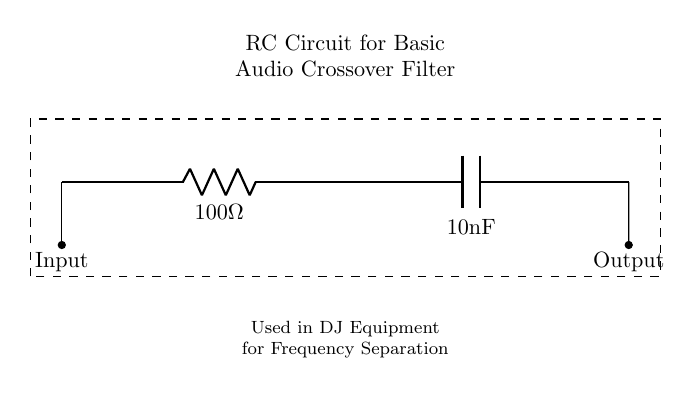What is the resistance value in this circuit? The resistance value is given directly in the circuit diagram next to the resistor symbol. It is labeled as 100 Ohms.
Answer: 100 Ohm What is the capacitance value in the circuit? The capacitance value is explicitly stated next to the capacitor symbol in the circuit diagram. It is labeled as 10 nanofarads.
Answer: 10 nanofarads What type of filter is this circuit designed to create? The RC circuit functions as a basic audio crossover filter, which is indicated in the title within the dashed rectangle of the circuit diagram.
Answer: Audio crossover filter What is the input to this RC circuit? The input to the circuit is designated by the connection point at the top left, where it is labeled "Input." This indicates where audio signals are fed into the circuit.
Answer: Input What happens to the signal frequency above a certain point? The role of the resistor and capacitor in this circuit is to allow only frequencies below a certain cutoff frequency to pass, while attenuating higher frequencies, which serves as a fundamental characteristic of an RC low-pass filter.
Answer: Attenuates higher frequencies What is the output of this circuit indicated as? The output point in the circuit is marked at the bottom right label "Output," signifying where the filtered audio signal exits the circuit.
Answer: Output How does changing the resistance value affect the cutoff frequency? The cutoff frequency of an RC circuit is inversely proportional to the resistance and capacitance values. By altering the resistance, you change the time constant, which can increase or decrease the cutoff frequency according to the formula, making it crucial for DJ equipment frequency settings.
Answer: Affects cutoff frequency 